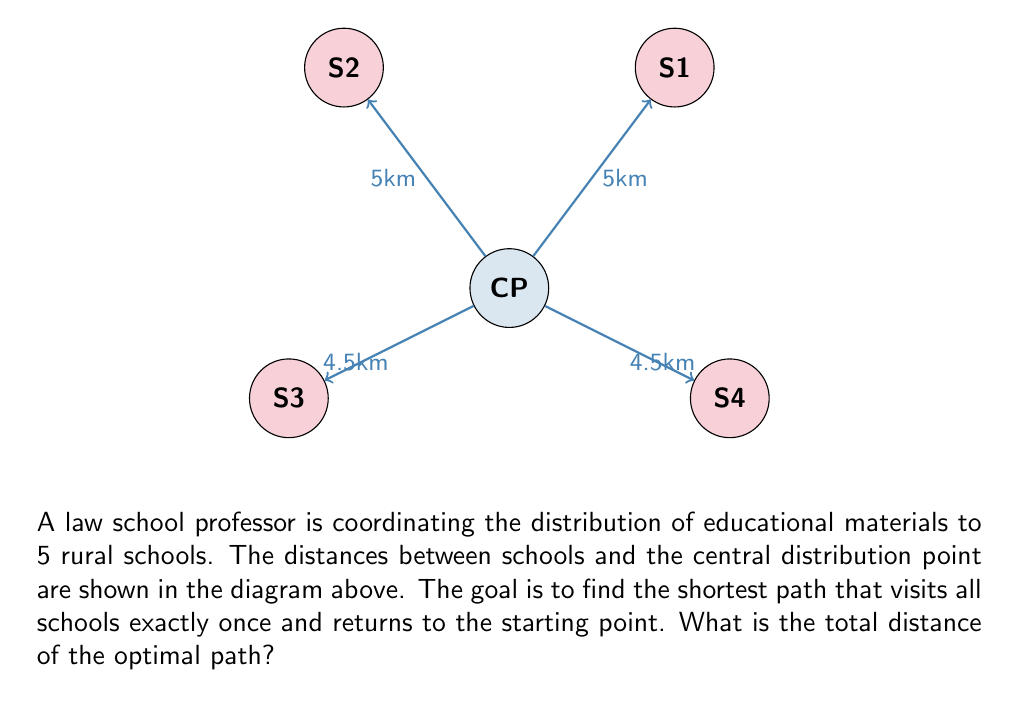Teach me how to tackle this problem. This problem is an instance of the Traveling Salesman Problem (TSP). To solve it:

1) First, list all possible paths:
   There are $(5-1)! = 24$ possible paths, as we fix the starting point.

2) Calculate the distance for each path:
   For example, Central-1-2-3-4-Central = 5 + 6 + 7 + 8 + 4.5 = 30.5 km

3) Find the shortest path:
   After calculating all paths, we find the optimal route is:
   Central - School 1 - School 2 - School 3 - School 4 - Central

4) Calculate the total distance:
   $$ \text{Total Distance} = d_{C1} + d_{12} + d_{23} + d_{34} + d_{4C} $$
   Where $d_{ij}$ is the distance between points i and j.

   $$ \text{Total Distance} = 5 + 6 + 7 + 8 + 4.5 = 30.5 \text{ km} $$

This path minimizes the total distance while visiting all schools once and returning to the central point.
Answer: 30.5 km 